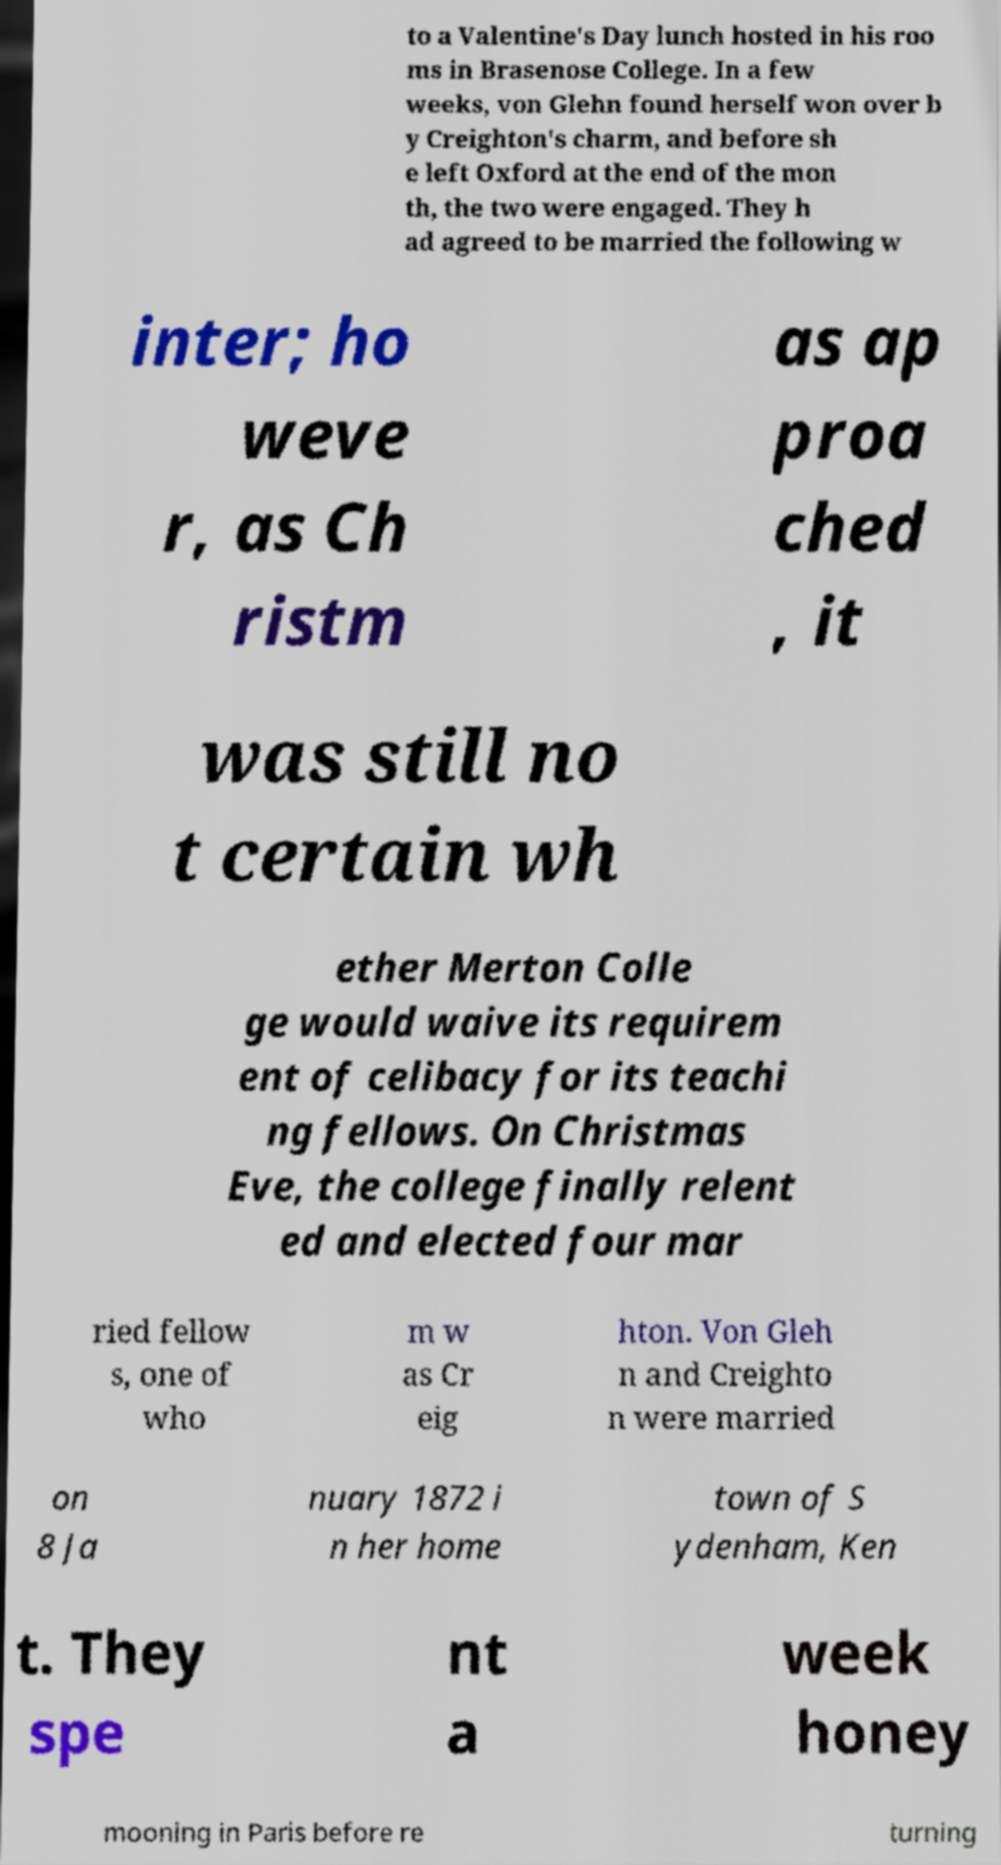Can you read and provide the text displayed in the image?This photo seems to have some interesting text. Can you extract and type it out for me? to a Valentine's Day lunch hosted in his roo ms in Brasenose College. In a few weeks, von Glehn found herself won over b y Creighton's charm, and before sh e left Oxford at the end of the mon th, the two were engaged. They h ad agreed to be married the following w inter; ho weve r, as Ch ristm as ap proa ched , it was still no t certain wh ether Merton Colle ge would waive its requirem ent of celibacy for its teachi ng fellows. On Christmas Eve, the college finally relent ed and elected four mar ried fellow s, one of who m w as Cr eig hton. Von Gleh n and Creighto n were married on 8 Ja nuary 1872 i n her home town of S ydenham, Ken t. They spe nt a week honey mooning in Paris before re turning 